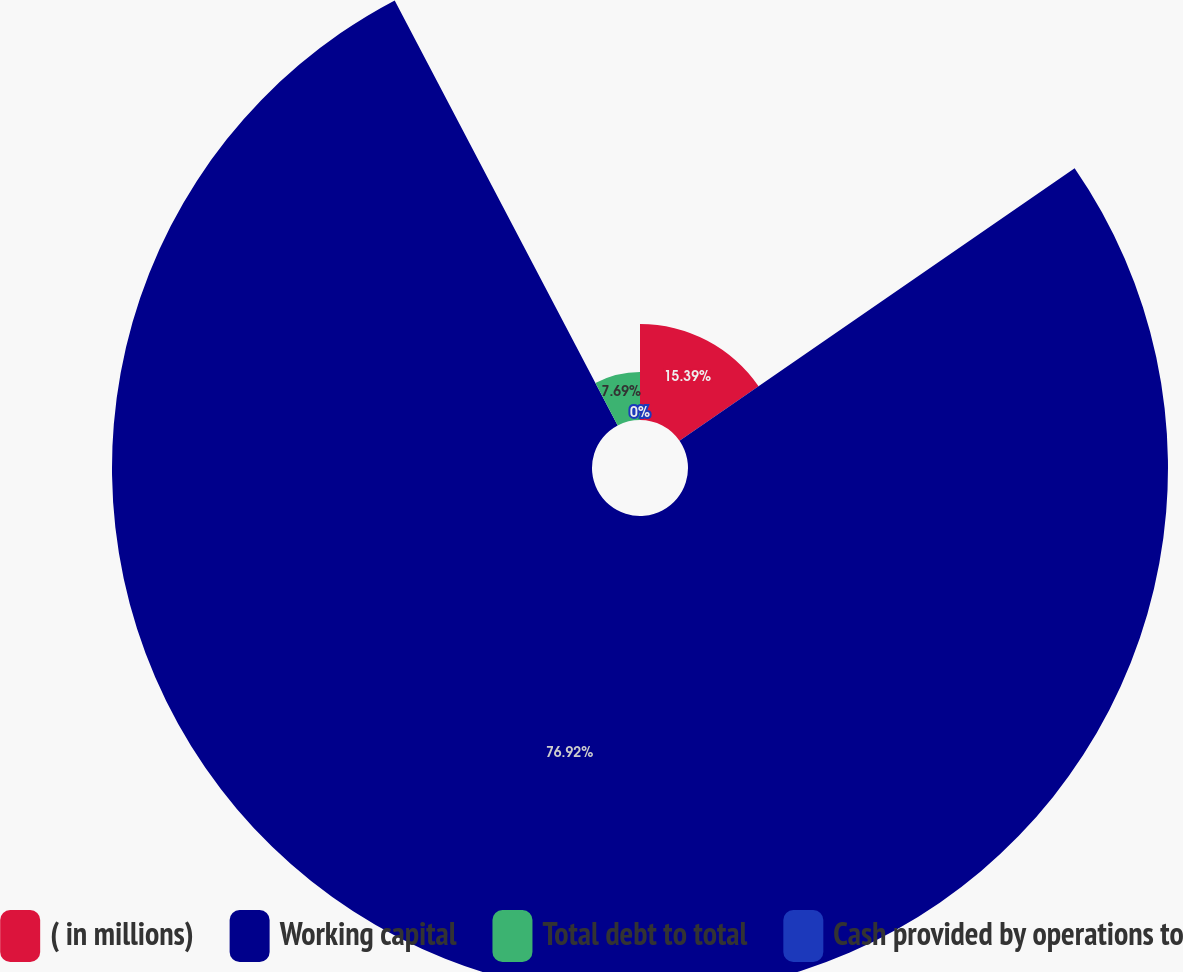Convert chart to OTSL. <chart><loc_0><loc_0><loc_500><loc_500><pie_chart><fcel>( in millions)<fcel>Working capital<fcel>Total debt to total<fcel>Cash provided by operations to<nl><fcel>15.39%<fcel>76.92%<fcel>7.69%<fcel>0.0%<nl></chart> 